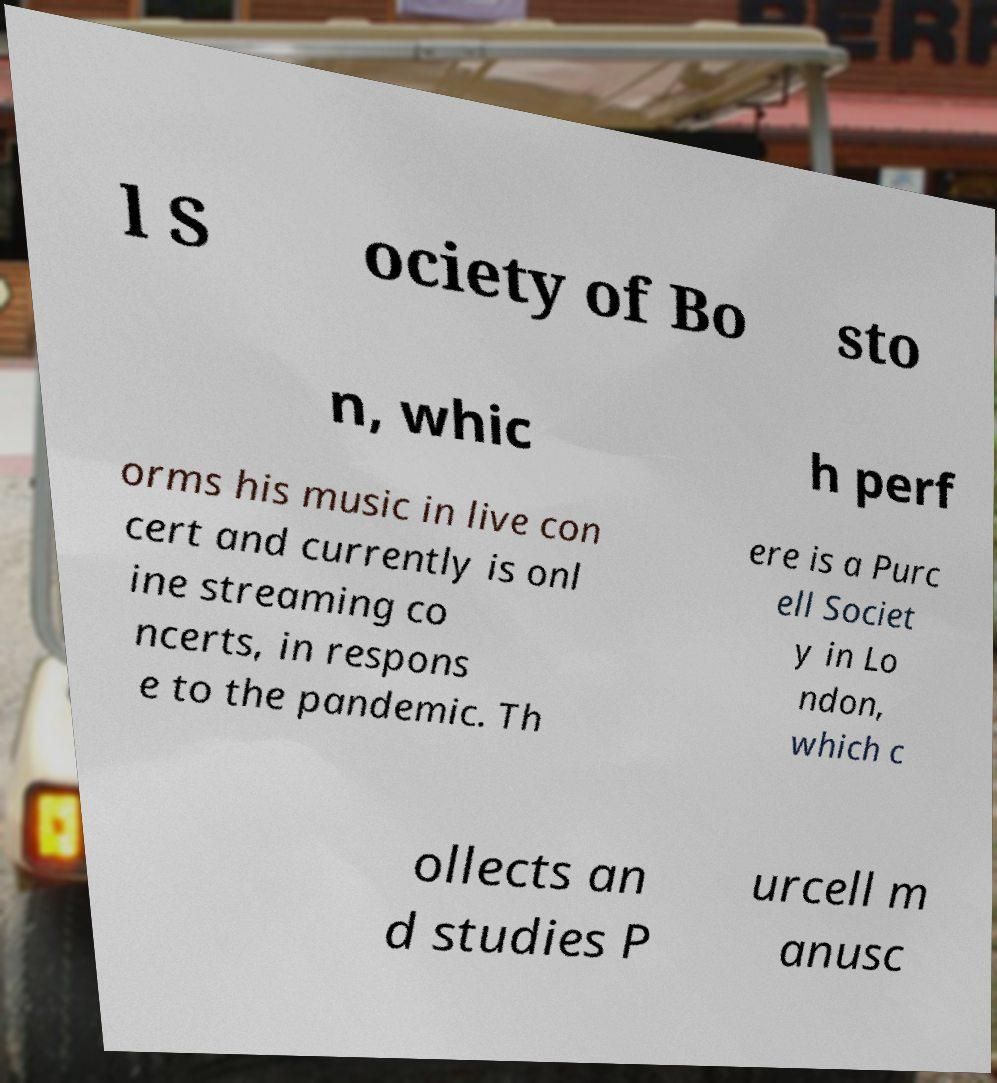For documentation purposes, I need the text within this image transcribed. Could you provide that? l S ociety of Bo sto n, whic h perf orms his music in live con cert and currently is onl ine streaming co ncerts, in respons e to the pandemic. Th ere is a Purc ell Societ y in Lo ndon, which c ollects an d studies P urcell m anusc 